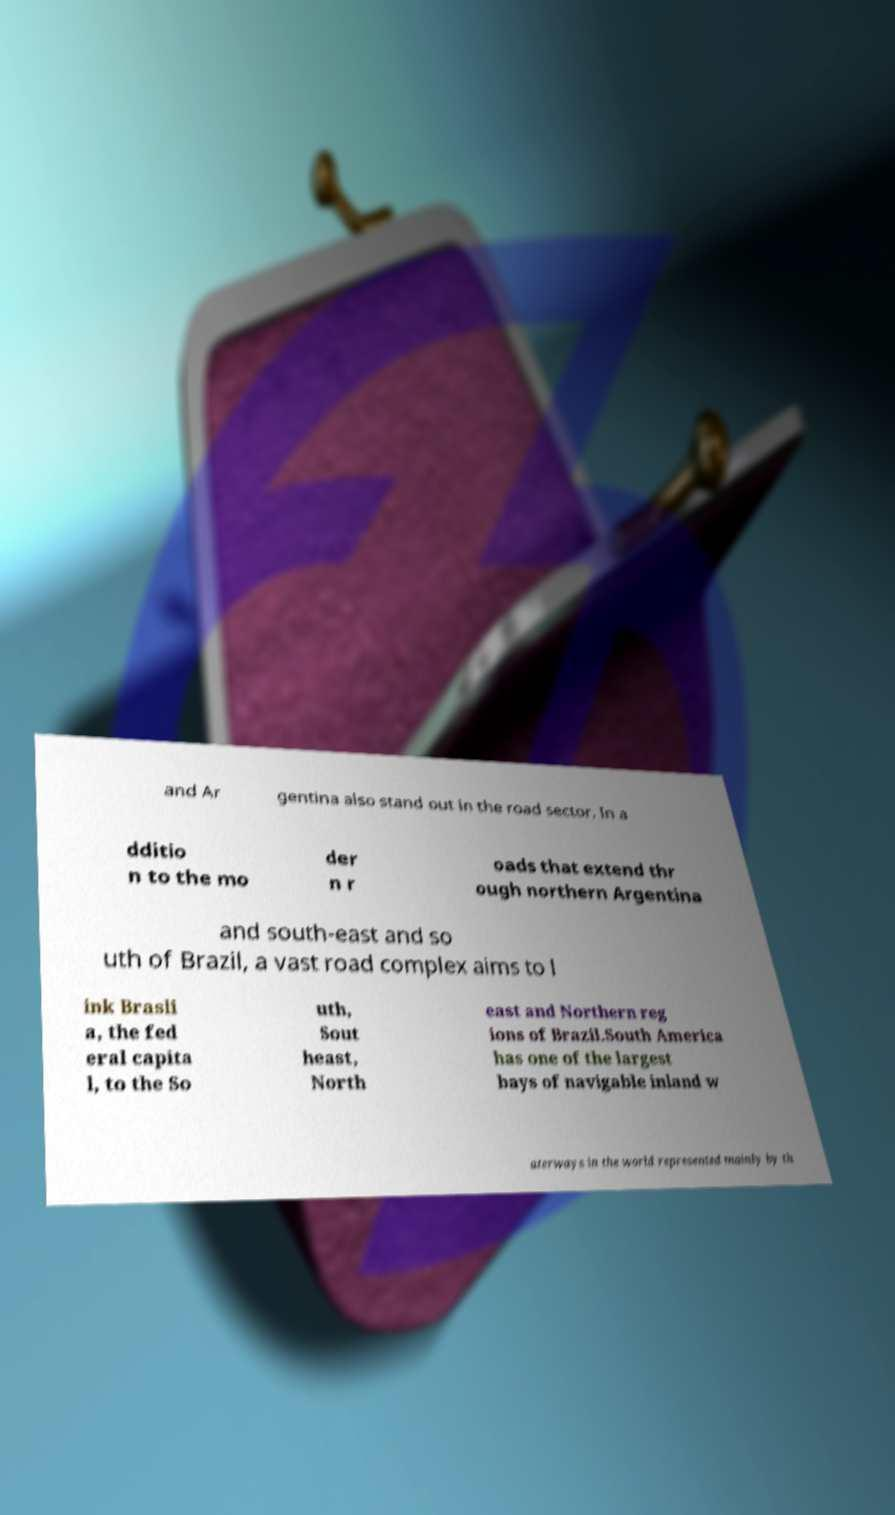I need the written content from this picture converted into text. Can you do that? and Ar gentina also stand out in the road sector. In a dditio n to the mo der n r oads that extend thr ough northern Argentina and south-east and so uth of Brazil, a vast road complex aims to l ink Brasli a, the fed eral capita l, to the So uth, Sout heast, North east and Northern reg ions of Brazil.South America has one of the largest bays of navigable inland w aterways in the world represented mainly by th 